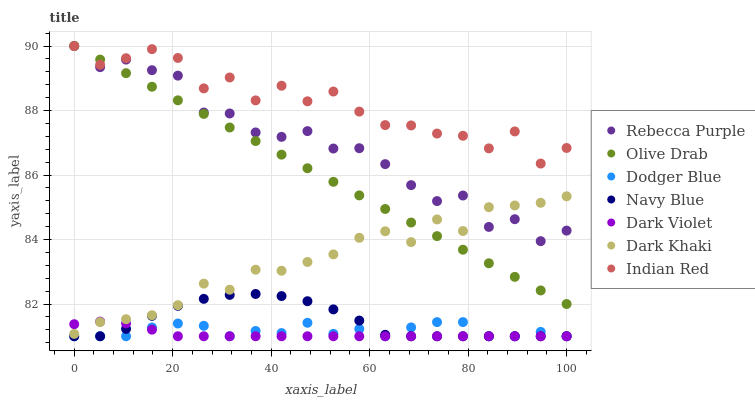Does Dark Violet have the minimum area under the curve?
Answer yes or no. Yes. Does Indian Red have the maximum area under the curve?
Answer yes or no. Yes. Does Dark Khaki have the minimum area under the curve?
Answer yes or no. No. Does Dark Khaki have the maximum area under the curve?
Answer yes or no. No. Is Olive Drab the smoothest?
Answer yes or no. Yes. Is Indian Red the roughest?
Answer yes or no. Yes. Is Dark Violet the smoothest?
Answer yes or no. No. Is Dark Violet the roughest?
Answer yes or no. No. Does Navy Blue have the lowest value?
Answer yes or no. Yes. Does Dark Khaki have the lowest value?
Answer yes or no. No. Does Olive Drab have the highest value?
Answer yes or no. Yes. Does Dark Violet have the highest value?
Answer yes or no. No. Is Dark Khaki less than Indian Red?
Answer yes or no. Yes. Is Rebecca Purple greater than Dodger Blue?
Answer yes or no. Yes. Does Dark Violet intersect Dark Khaki?
Answer yes or no. Yes. Is Dark Violet less than Dark Khaki?
Answer yes or no. No. Is Dark Violet greater than Dark Khaki?
Answer yes or no. No. Does Dark Khaki intersect Indian Red?
Answer yes or no. No. 